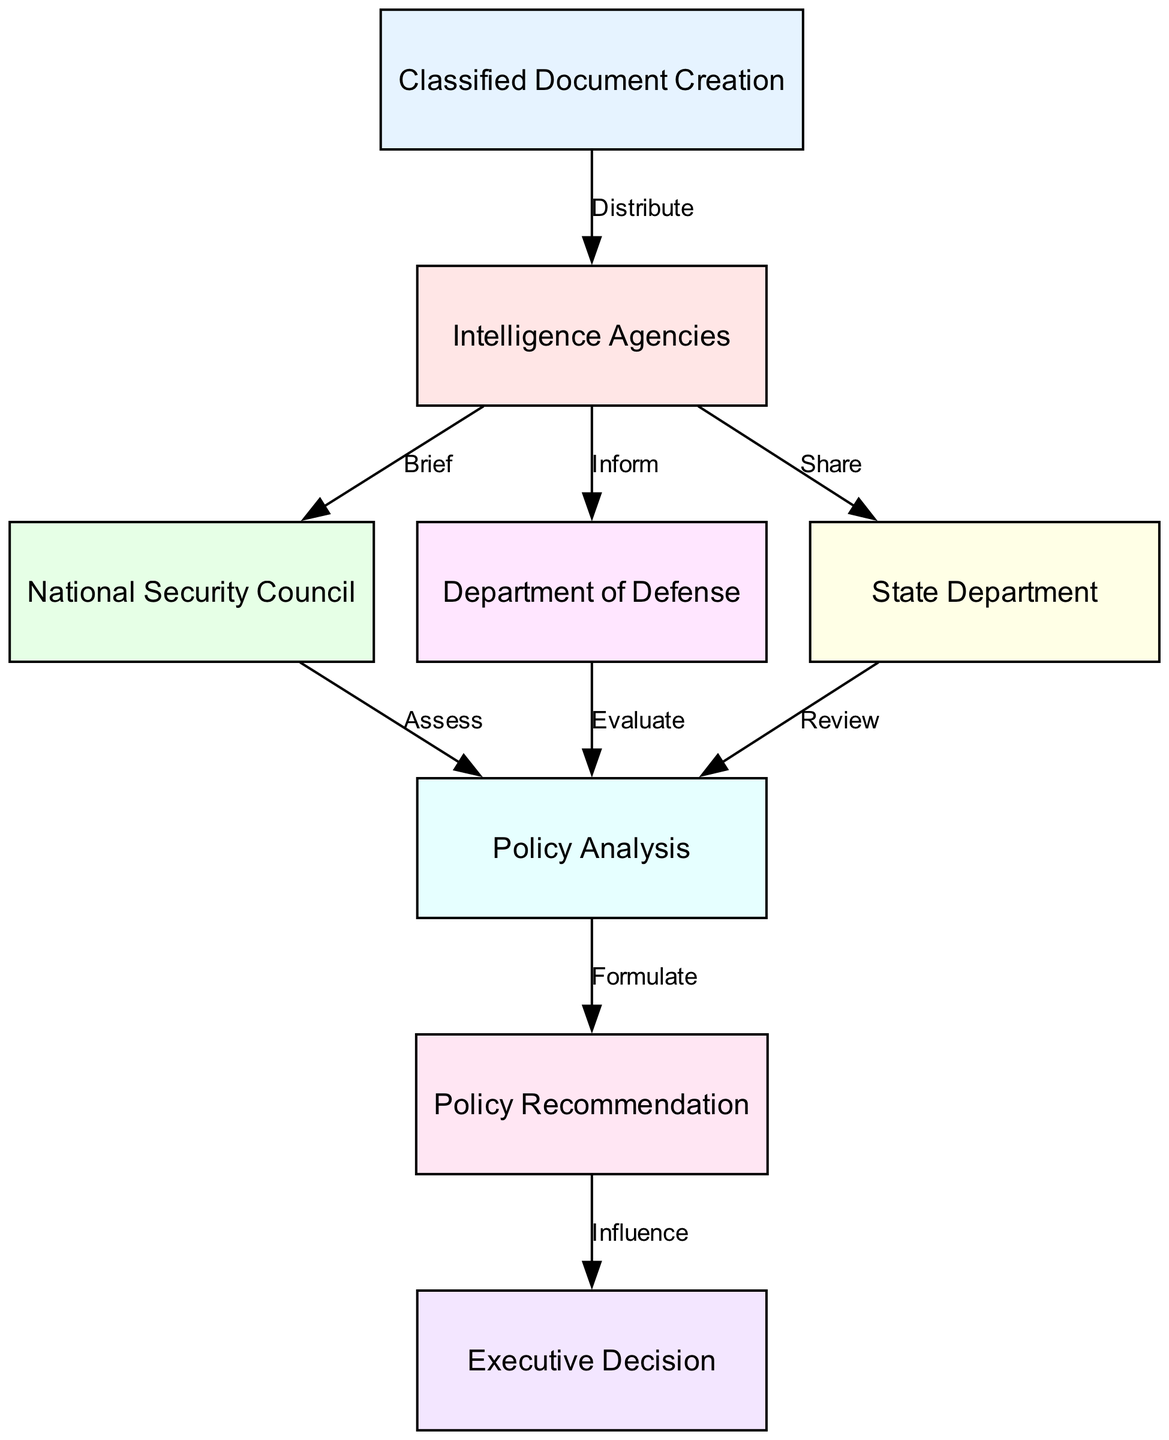What is the first step in the process? The first step in the process is "Classified Document Creation," which starts the flow in the diagram.
Answer: Classified Document Creation How many edges are in the diagram? By counting the connections between nodes, there are a total of 8 edges depicted in the diagram.
Answer: 8 Which departments receive information from intelligence agencies? The intelligence agencies share information with the National Security Council, the Department of Defense, and the State Department as indicated by the respective arrows.
Answer: National Security Council, Department of Defense, State Department What is the relationship between the National Security Council and Policy Analysis? The National Security Council "Assesses" the information received and leads to Policy Analysis, as shown by the directed edge from the National Security Council to Policy Analysis.
Answer: Assess Which node influences the Executive Decision? The node that influences the Executive Decision is the Policy Recommendation, which directly connects to the Executive Decision node in the diagram.
Answer: Policy Recommendation What is the function of the Policy Analysis step? The Policy Analysis step has the function of "Formulating" policy recommendations based on the assessments and evaluations from the previous nodes.
Answer: Formulate Which department evaluates the policy in conjunction with the Policy Analysis? The Department of Defense evaluates the policy in conjunction with the Policy Analysis, as represented by the edge that leads from the Department of Defense to Policy Analysis.
Answer: Evaluate What flow leads from Policy Recommendation to Executive Decision? The flow from Policy Recommendation to Executive Decision is marked by the word "Influence," indicating that the recommendations play a role in making executive decisions.
Answer: Influence 